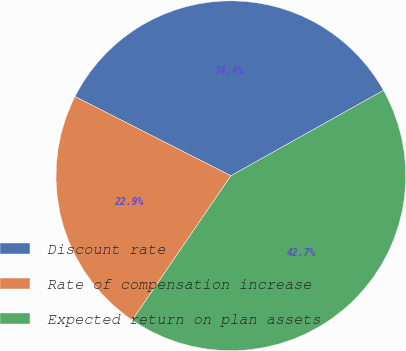Convert chart. <chart><loc_0><loc_0><loc_500><loc_500><pie_chart><fcel>Discount rate<fcel>Rate of compensation increase<fcel>Expected return on plan assets<nl><fcel>34.4%<fcel>22.95%<fcel>42.66%<nl></chart> 